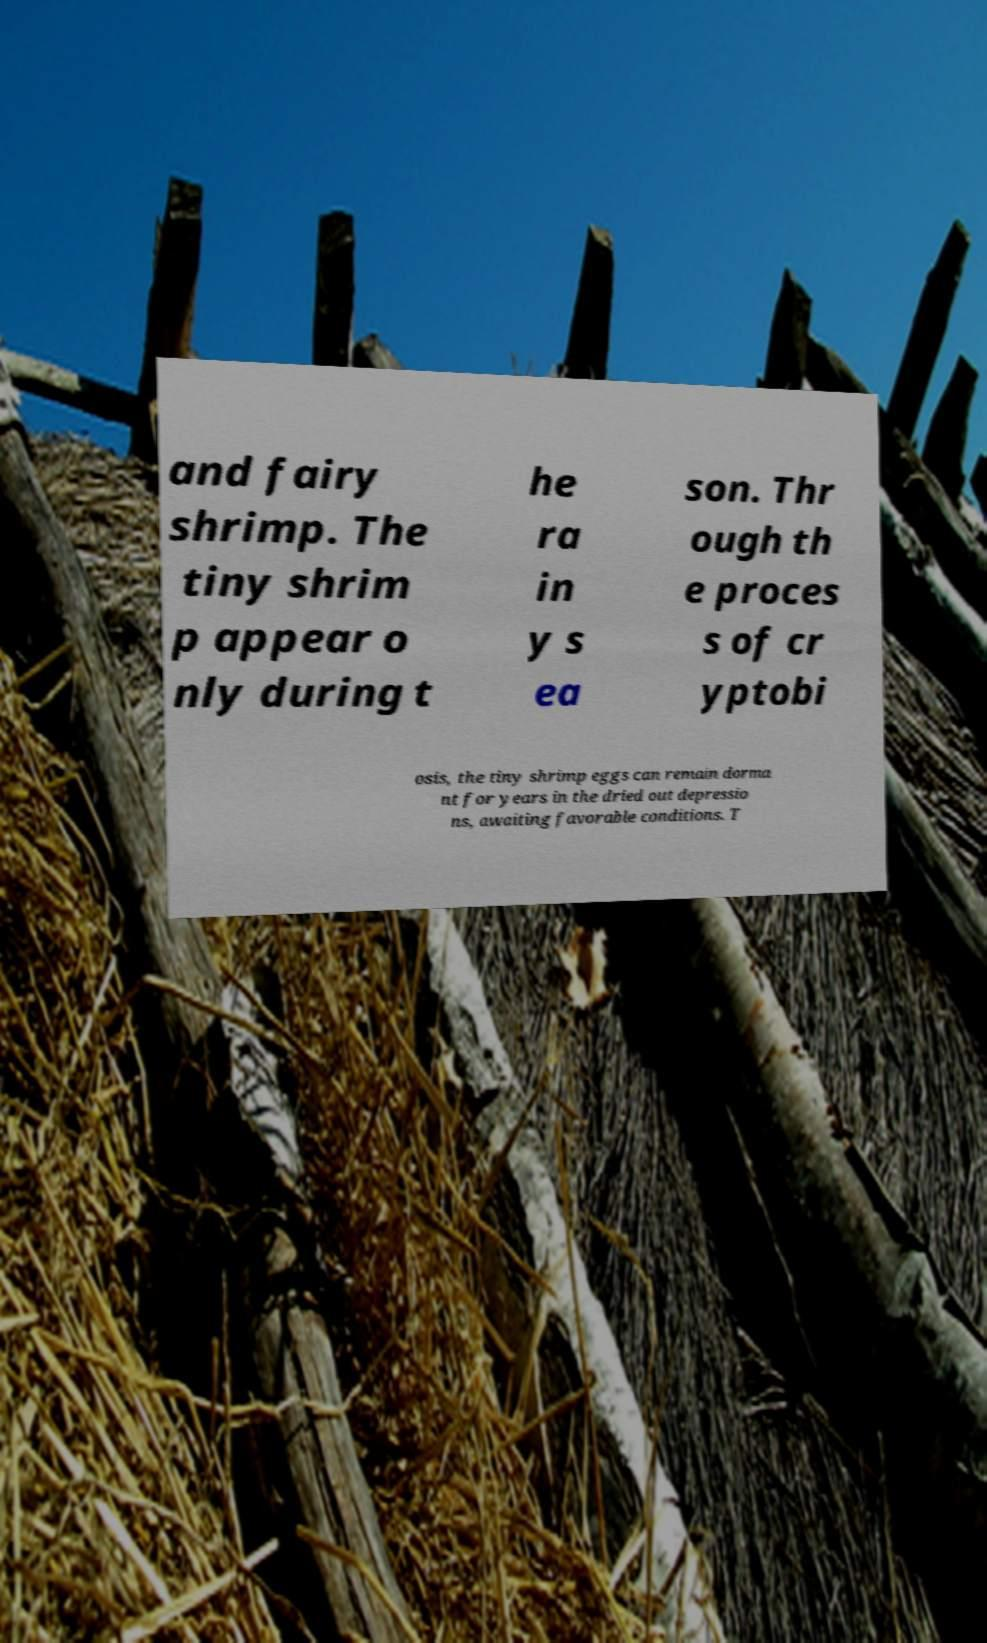Please read and relay the text visible in this image. What does it say? and fairy shrimp. The tiny shrim p appear o nly during t he ra in y s ea son. Thr ough th e proces s of cr yptobi osis, the tiny shrimp eggs can remain dorma nt for years in the dried out depressio ns, awaiting favorable conditions. T 